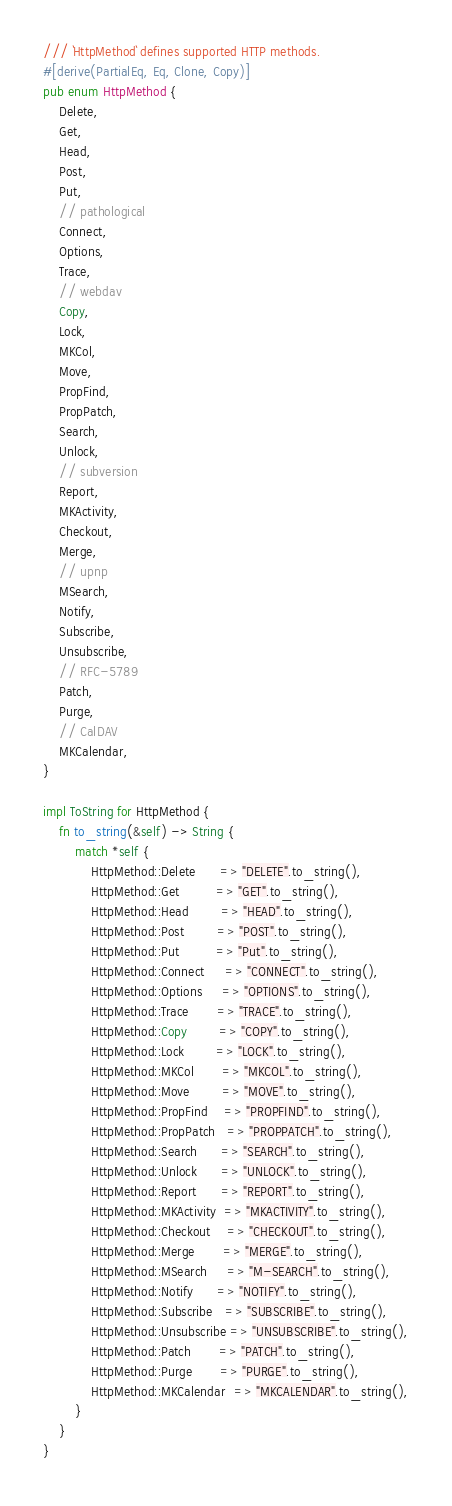<code> <loc_0><loc_0><loc_500><loc_500><_Rust_>/// `HttpMethod` defines supported HTTP methods.
#[derive(PartialEq, Eq, Clone, Copy)]
pub enum HttpMethod {
    Delete,
    Get,
    Head,
    Post,
    Put,
    // pathological
    Connect,
    Options,
    Trace,
    // webdav
    Copy,
    Lock,
    MKCol,
    Move,
    PropFind,
    PropPatch,
    Search,
    Unlock,
    // subversion
    Report,
    MKActivity,
    Checkout,
    Merge,
    // upnp
    MSearch,
    Notify,
    Subscribe,
    Unsubscribe,
    // RFC-5789
    Patch,
    Purge,
    // CalDAV
    MKCalendar,
}

impl ToString for HttpMethod {
    fn to_string(&self) -> String {
        match *self {
            HttpMethod::Delete      => "DELETE".to_string(),
            HttpMethod::Get         => "GET".to_string(),
            HttpMethod::Head        => "HEAD".to_string(),
            HttpMethod::Post        => "POST".to_string(),
            HttpMethod::Put         => "Put".to_string(),
            HttpMethod::Connect     => "CONNECT".to_string(),
            HttpMethod::Options     => "OPTIONS".to_string(),
            HttpMethod::Trace       => "TRACE".to_string(),
            HttpMethod::Copy        => "COPY".to_string(),
            HttpMethod::Lock        => "LOCK".to_string(),
            HttpMethod::MKCol       => "MKCOL".to_string(),
            HttpMethod::Move        => "MOVE".to_string(),
            HttpMethod::PropFind    => "PROPFIND".to_string(),
            HttpMethod::PropPatch   => "PROPPATCH".to_string(),
            HttpMethod::Search      => "SEARCH".to_string(),
            HttpMethod::Unlock      => "UNLOCK".to_string(),
            HttpMethod::Report      => "REPORT".to_string(),
            HttpMethod::MKActivity  => "MKACTIVITY".to_string(),
            HttpMethod::Checkout    => "CHECKOUT".to_string(),
            HttpMethod::Merge       => "MERGE".to_string(),
            HttpMethod::MSearch     => "M-SEARCH".to_string(),
            HttpMethod::Notify      => "NOTIFY".to_string(),
            HttpMethod::Subscribe   => "SUBSCRIBE".to_string(),
            HttpMethod::Unsubscribe => "UNSUBSCRIBE".to_string(),
            HttpMethod::Patch       => "PATCH".to_string(),
            HttpMethod::Purge       => "PURGE".to_string(),
            HttpMethod::MKCalendar  => "MKCALENDAR".to_string(),
        }
    }
}
</code> 